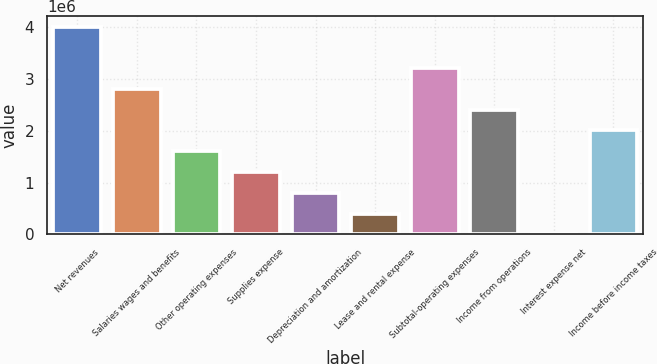<chart> <loc_0><loc_0><loc_500><loc_500><bar_chart><fcel>Net revenues<fcel>Salaries wages and benefits<fcel>Other operating expenses<fcel>Supplies expense<fcel>Depreciation and amortization<fcel>Lease and rental expense<fcel>Subtotal-operating expenses<fcel>Income from operations<fcel>Interest expense net<fcel>Income before income taxes<nl><fcel>4.01222e+06<fcel>2.80913e+06<fcel>1.60604e+06<fcel>1.20501e+06<fcel>803977<fcel>402947<fcel>3.21016e+06<fcel>2.4081e+06<fcel>1917<fcel>2.00707e+06<nl></chart> 